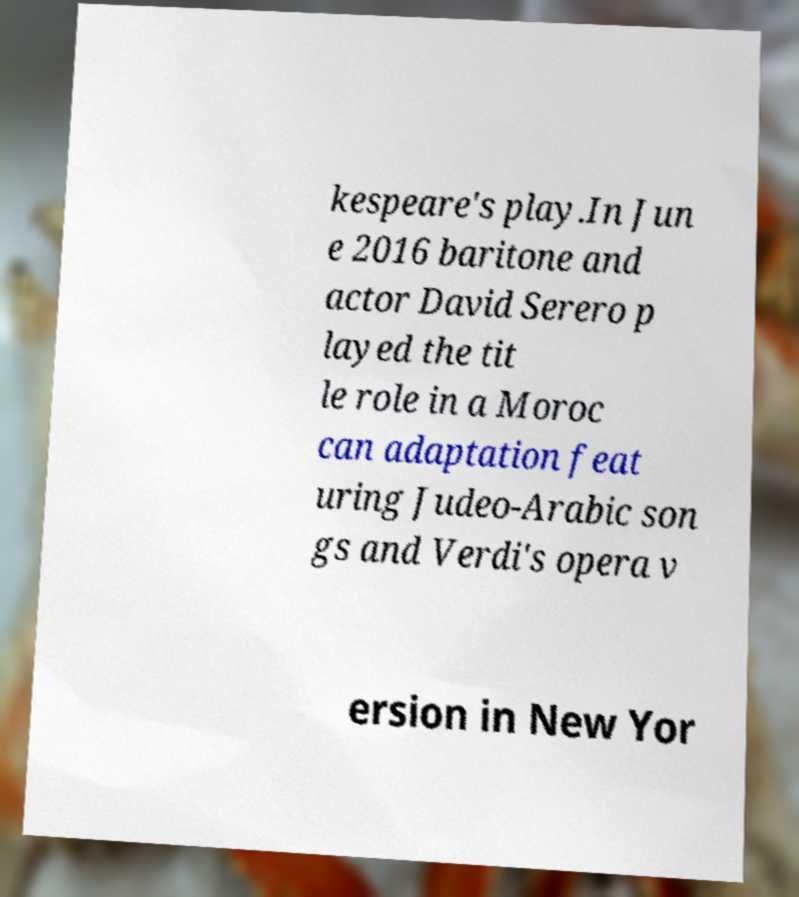For documentation purposes, I need the text within this image transcribed. Could you provide that? kespeare's play.In Jun e 2016 baritone and actor David Serero p layed the tit le role in a Moroc can adaptation feat uring Judeo-Arabic son gs and Verdi's opera v ersion in New Yor 